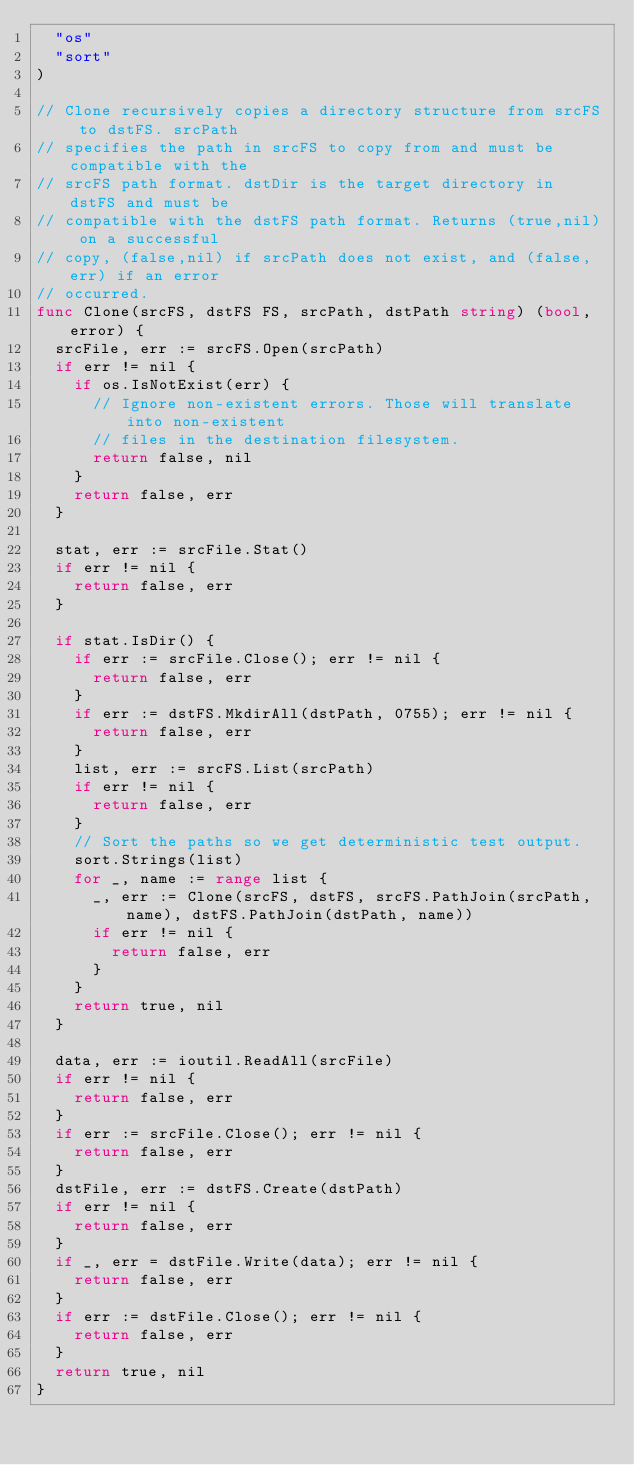<code> <loc_0><loc_0><loc_500><loc_500><_Go_>	"os"
	"sort"
)

// Clone recursively copies a directory structure from srcFS to dstFS. srcPath
// specifies the path in srcFS to copy from and must be compatible with the
// srcFS path format. dstDir is the target directory in dstFS and must be
// compatible with the dstFS path format. Returns (true,nil) on a successful
// copy, (false,nil) if srcPath does not exist, and (false,err) if an error
// occurred.
func Clone(srcFS, dstFS FS, srcPath, dstPath string) (bool, error) {
	srcFile, err := srcFS.Open(srcPath)
	if err != nil {
		if os.IsNotExist(err) {
			// Ignore non-existent errors. Those will translate into non-existent
			// files in the destination filesystem.
			return false, nil
		}
		return false, err
	}

	stat, err := srcFile.Stat()
	if err != nil {
		return false, err
	}

	if stat.IsDir() {
		if err := srcFile.Close(); err != nil {
			return false, err
		}
		if err := dstFS.MkdirAll(dstPath, 0755); err != nil {
			return false, err
		}
		list, err := srcFS.List(srcPath)
		if err != nil {
			return false, err
		}
		// Sort the paths so we get deterministic test output.
		sort.Strings(list)
		for _, name := range list {
			_, err := Clone(srcFS, dstFS, srcFS.PathJoin(srcPath, name), dstFS.PathJoin(dstPath, name))
			if err != nil {
				return false, err
			}
		}
		return true, nil
	}

	data, err := ioutil.ReadAll(srcFile)
	if err != nil {
		return false, err
	}
	if err := srcFile.Close(); err != nil {
		return false, err
	}
	dstFile, err := dstFS.Create(dstPath)
	if err != nil {
		return false, err
	}
	if _, err = dstFile.Write(data); err != nil {
		return false, err
	}
	if err := dstFile.Close(); err != nil {
		return false, err
	}
	return true, nil
}
</code> 